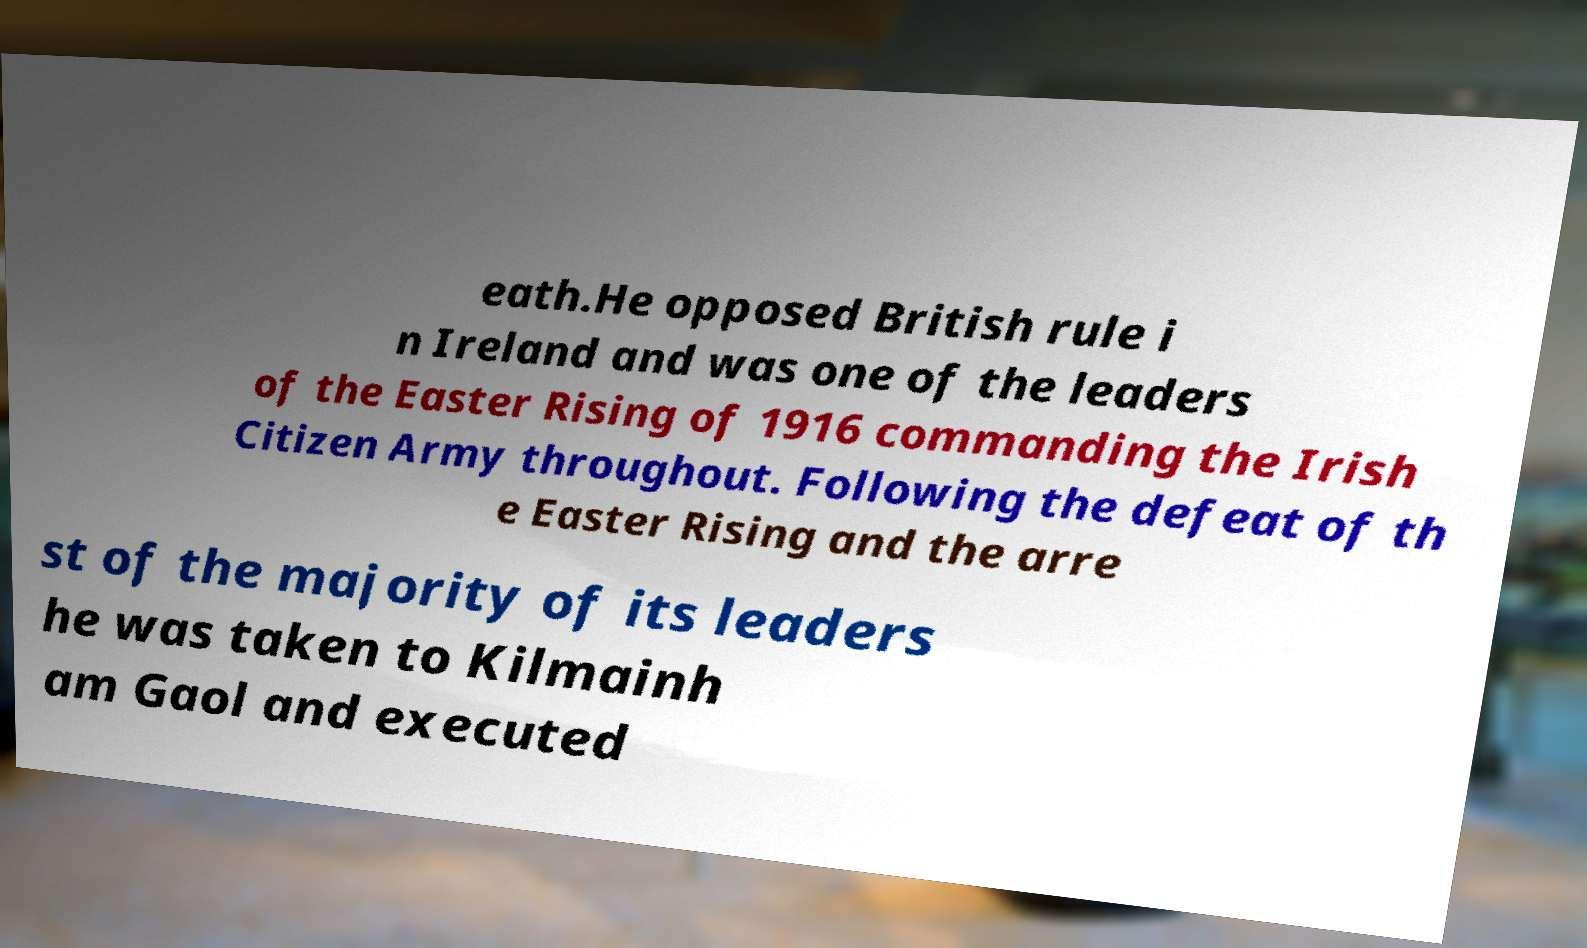Could you extract and type out the text from this image? eath.He opposed British rule i n Ireland and was one of the leaders of the Easter Rising of 1916 commanding the Irish Citizen Army throughout. Following the defeat of th e Easter Rising and the arre st of the majority of its leaders he was taken to Kilmainh am Gaol and executed 